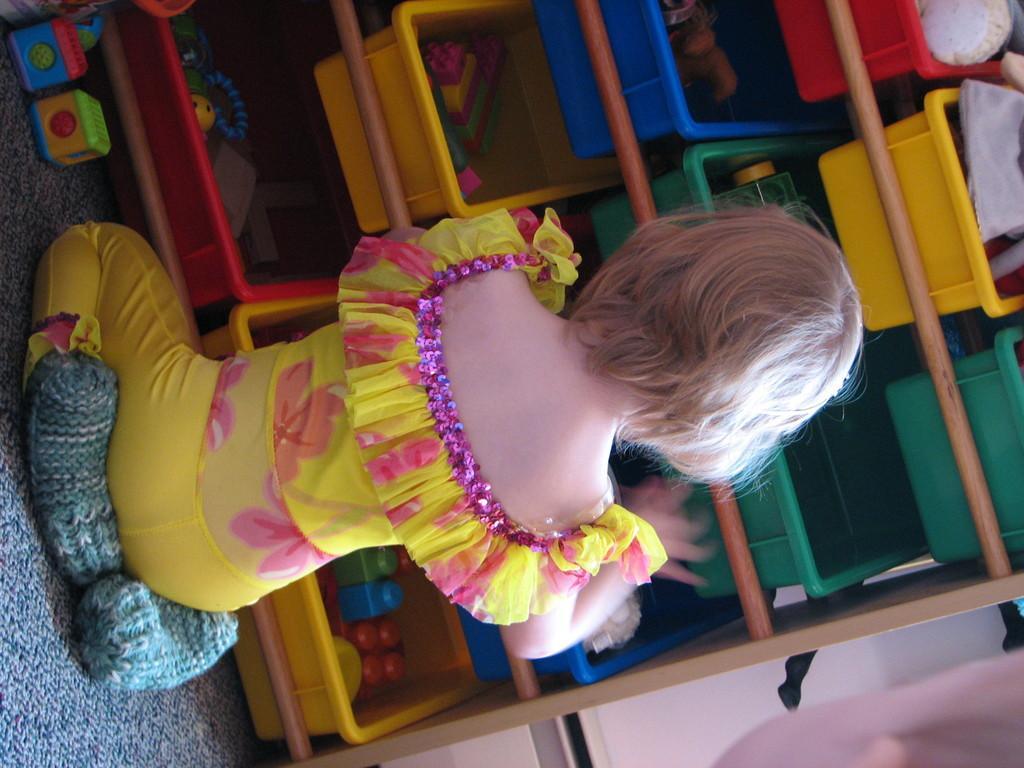In one or two sentences, can you explain what this image depicts? In the image of the image a girl is sitting. In front of her we can see some baskets, in the baskets we can see some toys. Behind them we can see a wall. In the bottom right corner of the image we can see a person face. 